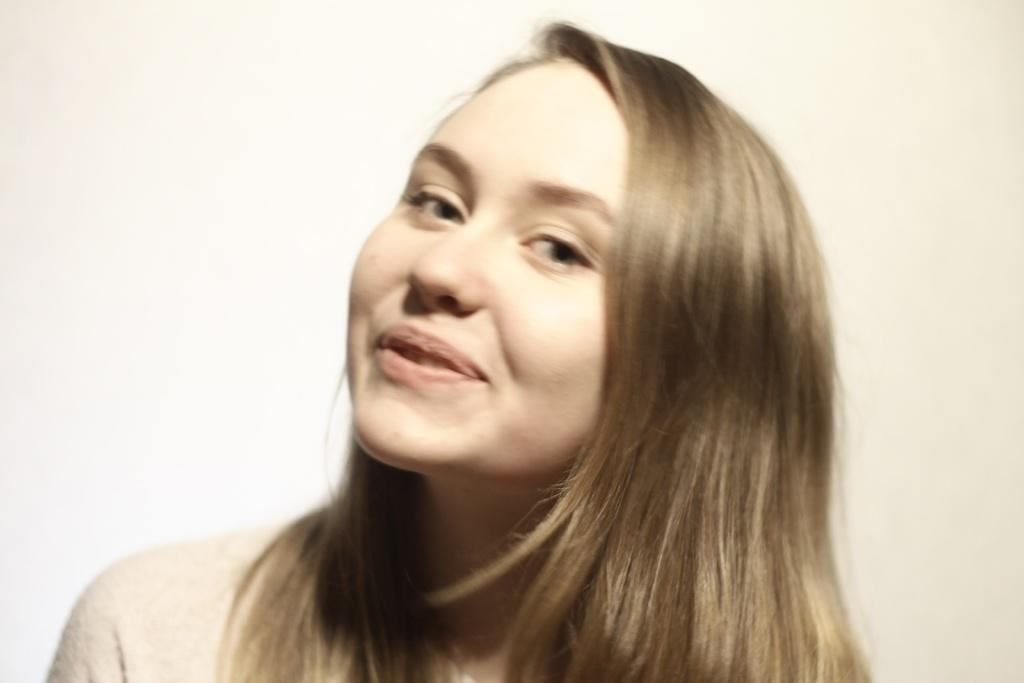Who is present in the image? There is a woman in the image. What expression does the woman have? The woman is smiling. What can be seen in the background of the image? There is a wall in the background of the image. What type of yarn is the actor using in the image? There is no actor or yarn present in the image; it features a woman who is smiling. How does the expansion of the image affect its resolution? The image's resolution is not affected by its expansion, as the image is static and not subject to changes in size or quality. 